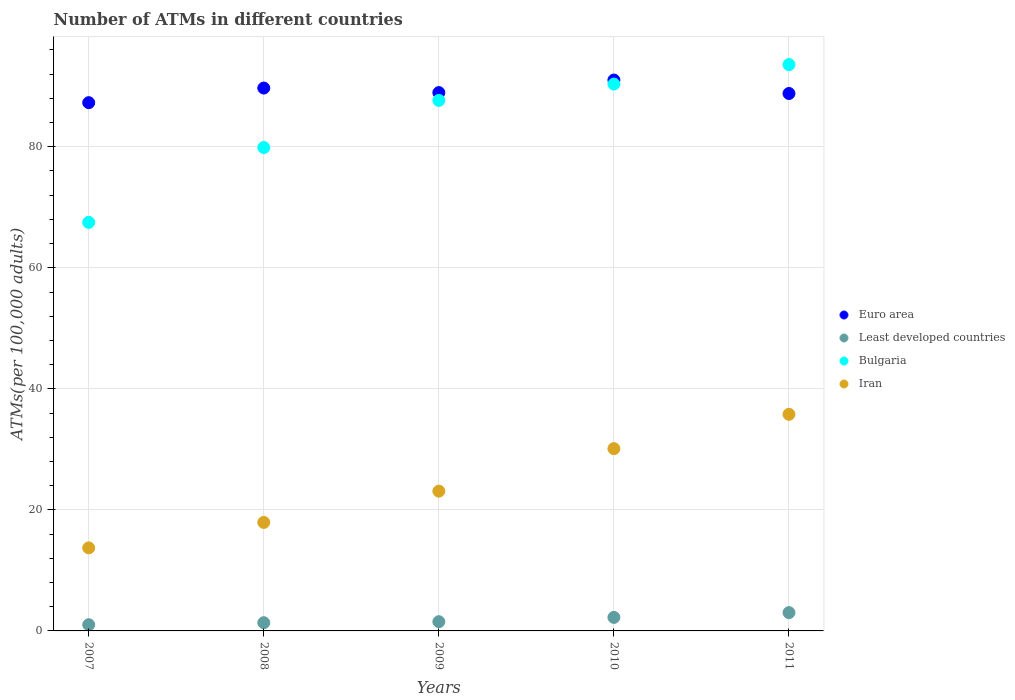How many different coloured dotlines are there?
Keep it short and to the point. 4. Is the number of dotlines equal to the number of legend labels?
Ensure brevity in your answer.  Yes. What is the number of ATMs in Euro area in 2007?
Provide a succinct answer. 87.29. Across all years, what is the maximum number of ATMs in Euro area?
Make the answer very short. 91.03. Across all years, what is the minimum number of ATMs in Bulgaria?
Your answer should be very brief. 67.51. In which year was the number of ATMs in Iran minimum?
Give a very brief answer. 2007. What is the total number of ATMs in Bulgaria in the graph?
Give a very brief answer. 419. What is the difference between the number of ATMs in Least developed countries in 2008 and that in 2010?
Offer a terse response. -0.87. What is the difference between the number of ATMs in Iran in 2010 and the number of ATMs in Least developed countries in 2008?
Make the answer very short. 28.76. What is the average number of ATMs in Least developed countries per year?
Provide a short and direct response. 1.83. In the year 2009, what is the difference between the number of ATMs in Least developed countries and number of ATMs in Bulgaria?
Keep it short and to the point. -86.14. In how many years, is the number of ATMs in Euro area greater than 64?
Offer a terse response. 5. What is the ratio of the number of ATMs in Iran in 2009 to that in 2010?
Keep it short and to the point. 0.77. Is the number of ATMs in Iran in 2007 less than that in 2011?
Keep it short and to the point. Yes. Is the difference between the number of ATMs in Least developed countries in 2008 and 2009 greater than the difference between the number of ATMs in Bulgaria in 2008 and 2009?
Provide a short and direct response. Yes. What is the difference between the highest and the second highest number of ATMs in Iran?
Your answer should be compact. 5.67. What is the difference between the highest and the lowest number of ATMs in Least developed countries?
Provide a succinct answer. 2. Is it the case that in every year, the sum of the number of ATMs in Iran and number of ATMs in Euro area  is greater than the sum of number of ATMs in Bulgaria and number of ATMs in Least developed countries?
Offer a very short reply. No. Is it the case that in every year, the sum of the number of ATMs in Least developed countries and number of ATMs in Bulgaria  is greater than the number of ATMs in Iran?
Keep it short and to the point. Yes. Is the number of ATMs in Least developed countries strictly less than the number of ATMs in Bulgaria over the years?
Your response must be concise. Yes. How many years are there in the graph?
Keep it short and to the point. 5. What is the difference between two consecutive major ticks on the Y-axis?
Your answer should be very brief. 20. Are the values on the major ticks of Y-axis written in scientific E-notation?
Give a very brief answer. No. Does the graph contain grids?
Provide a short and direct response. Yes. Where does the legend appear in the graph?
Offer a terse response. Center right. What is the title of the graph?
Ensure brevity in your answer.  Number of ATMs in different countries. Does "High income: nonOECD" appear as one of the legend labels in the graph?
Give a very brief answer. No. What is the label or title of the X-axis?
Offer a terse response. Years. What is the label or title of the Y-axis?
Your response must be concise. ATMs(per 100,0 adults). What is the ATMs(per 100,000 adults) in Euro area in 2007?
Keep it short and to the point. 87.29. What is the ATMs(per 100,000 adults) in Least developed countries in 2007?
Offer a terse response. 1.03. What is the ATMs(per 100,000 adults) in Bulgaria in 2007?
Your answer should be compact. 67.51. What is the ATMs(per 100,000 adults) in Iran in 2007?
Your answer should be compact. 13.73. What is the ATMs(per 100,000 adults) in Euro area in 2008?
Make the answer very short. 89.71. What is the ATMs(per 100,000 adults) of Least developed countries in 2008?
Give a very brief answer. 1.36. What is the ATMs(per 100,000 adults) of Bulgaria in 2008?
Offer a very short reply. 79.88. What is the ATMs(per 100,000 adults) in Iran in 2008?
Provide a short and direct response. 17.93. What is the ATMs(per 100,000 adults) in Euro area in 2009?
Your response must be concise. 88.96. What is the ATMs(per 100,000 adults) in Least developed countries in 2009?
Your answer should be compact. 1.53. What is the ATMs(per 100,000 adults) in Bulgaria in 2009?
Offer a terse response. 87.66. What is the ATMs(per 100,000 adults) in Iran in 2009?
Give a very brief answer. 23.09. What is the ATMs(per 100,000 adults) of Euro area in 2010?
Give a very brief answer. 91.03. What is the ATMs(per 100,000 adults) in Least developed countries in 2010?
Your answer should be compact. 2.23. What is the ATMs(per 100,000 adults) in Bulgaria in 2010?
Offer a very short reply. 90.36. What is the ATMs(per 100,000 adults) in Iran in 2010?
Your answer should be compact. 30.12. What is the ATMs(per 100,000 adults) of Euro area in 2011?
Ensure brevity in your answer.  88.81. What is the ATMs(per 100,000 adults) in Least developed countries in 2011?
Provide a succinct answer. 3.02. What is the ATMs(per 100,000 adults) of Bulgaria in 2011?
Offer a terse response. 93.58. What is the ATMs(per 100,000 adults) in Iran in 2011?
Provide a succinct answer. 35.79. Across all years, what is the maximum ATMs(per 100,000 adults) in Euro area?
Keep it short and to the point. 91.03. Across all years, what is the maximum ATMs(per 100,000 adults) in Least developed countries?
Your answer should be compact. 3.02. Across all years, what is the maximum ATMs(per 100,000 adults) in Bulgaria?
Keep it short and to the point. 93.58. Across all years, what is the maximum ATMs(per 100,000 adults) of Iran?
Your response must be concise. 35.79. Across all years, what is the minimum ATMs(per 100,000 adults) of Euro area?
Your response must be concise. 87.29. Across all years, what is the minimum ATMs(per 100,000 adults) of Least developed countries?
Offer a terse response. 1.03. Across all years, what is the minimum ATMs(per 100,000 adults) of Bulgaria?
Ensure brevity in your answer.  67.51. Across all years, what is the minimum ATMs(per 100,000 adults) of Iran?
Make the answer very short. 13.73. What is the total ATMs(per 100,000 adults) in Euro area in the graph?
Provide a succinct answer. 445.79. What is the total ATMs(per 100,000 adults) in Least developed countries in the graph?
Provide a succinct answer. 9.17. What is the total ATMs(per 100,000 adults) in Bulgaria in the graph?
Make the answer very short. 419. What is the total ATMs(per 100,000 adults) of Iran in the graph?
Keep it short and to the point. 120.67. What is the difference between the ATMs(per 100,000 adults) of Euro area in 2007 and that in 2008?
Provide a succinct answer. -2.42. What is the difference between the ATMs(per 100,000 adults) of Least developed countries in 2007 and that in 2008?
Offer a terse response. -0.33. What is the difference between the ATMs(per 100,000 adults) in Bulgaria in 2007 and that in 2008?
Ensure brevity in your answer.  -12.37. What is the difference between the ATMs(per 100,000 adults) of Iran in 2007 and that in 2008?
Your answer should be compact. -4.2. What is the difference between the ATMs(per 100,000 adults) of Euro area in 2007 and that in 2009?
Your response must be concise. -1.67. What is the difference between the ATMs(per 100,000 adults) of Least developed countries in 2007 and that in 2009?
Offer a very short reply. -0.5. What is the difference between the ATMs(per 100,000 adults) in Bulgaria in 2007 and that in 2009?
Keep it short and to the point. -20.16. What is the difference between the ATMs(per 100,000 adults) in Iran in 2007 and that in 2009?
Provide a succinct answer. -9.37. What is the difference between the ATMs(per 100,000 adults) of Euro area in 2007 and that in 2010?
Your answer should be very brief. -3.74. What is the difference between the ATMs(per 100,000 adults) in Least developed countries in 2007 and that in 2010?
Your answer should be compact. -1.21. What is the difference between the ATMs(per 100,000 adults) in Bulgaria in 2007 and that in 2010?
Your response must be concise. -22.86. What is the difference between the ATMs(per 100,000 adults) of Iran in 2007 and that in 2010?
Your answer should be very brief. -16.4. What is the difference between the ATMs(per 100,000 adults) of Euro area in 2007 and that in 2011?
Keep it short and to the point. -1.52. What is the difference between the ATMs(per 100,000 adults) in Least developed countries in 2007 and that in 2011?
Offer a terse response. -2. What is the difference between the ATMs(per 100,000 adults) in Bulgaria in 2007 and that in 2011?
Ensure brevity in your answer.  -26.08. What is the difference between the ATMs(per 100,000 adults) of Iran in 2007 and that in 2011?
Make the answer very short. -22.07. What is the difference between the ATMs(per 100,000 adults) in Euro area in 2008 and that in 2009?
Keep it short and to the point. 0.75. What is the difference between the ATMs(per 100,000 adults) in Least developed countries in 2008 and that in 2009?
Offer a very short reply. -0.17. What is the difference between the ATMs(per 100,000 adults) of Bulgaria in 2008 and that in 2009?
Your response must be concise. -7.78. What is the difference between the ATMs(per 100,000 adults) of Iran in 2008 and that in 2009?
Offer a very short reply. -5.17. What is the difference between the ATMs(per 100,000 adults) in Euro area in 2008 and that in 2010?
Make the answer very short. -1.32. What is the difference between the ATMs(per 100,000 adults) of Least developed countries in 2008 and that in 2010?
Offer a terse response. -0.87. What is the difference between the ATMs(per 100,000 adults) of Bulgaria in 2008 and that in 2010?
Make the answer very short. -10.48. What is the difference between the ATMs(per 100,000 adults) of Iran in 2008 and that in 2010?
Provide a succinct answer. -12.19. What is the difference between the ATMs(per 100,000 adults) of Euro area in 2008 and that in 2011?
Provide a succinct answer. 0.9. What is the difference between the ATMs(per 100,000 adults) in Least developed countries in 2008 and that in 2011?
Your answer should be very brief. -1.66. What is the difference between the ATMs(per 100,000 adults) of Bulgaria in 2008 and that in 2011?
Ensure brevity in your answer.  -13.7. What is the difference between the ATMs(per 100,000 adults) in Iran in 2008 and that in 2011?
Offer a terse response. -17.86. What is the difference between the ATMs(per 100,000 adults) of Euro area in 2009 and that in 2010?
Provide a short and direct response. -2.07. What is the difference between the ATMs(per 100,000 adults) of Least developed countries in 2009 and that in 2010?
Offer a terse response. -0.71. What is the difference between the ATMs(per 100,000 adults) of Bulgaria in 2009 and that in 2010?
Ensure brevity in your answer.  -2.7. What is the difference between the ATMs(per 100,000 adults) in Iran in 2009 and that in 2010?
Your response must be concise. -7.03. What is the difference between the ATMs(per 100,000 adults) of Euro area in 2009 and that in 2011?
Provide a short and direct response. 0.15. What is the difference between the ATMs(per 100,000 adults) of Least developed countries in 2009 and that in 2011?
Give a very brief answer. -1.5. What is the difference between the ATMs(per 100,000 adults) of Bulgaria in 2009 and that in 2011?
Keep it short and to the point. -5.92. What is the difference between the ATMs(per 100,000 adults) in Iran in 2009 and that in 2011?
Your answer should be very brief. -12.7. What is the difference between the ATMs(per 100,000 adults) in Euro area in 2010 and that in 2011?
Offer a terse response. 2.22. What is the difference between the ATMs(per 100,000 adults) in Least developed countries in 2010 and that in 2011?
Your answer should be very brief. -0.79. What is the difference between the ATMs(per 100,000 adults) in Bulgaria in 2010 and that in 2011?
Offer a very short reply. -3.22. What is the difference between the ATMs(per 100,000 adults) in Iran in 2010 and that in 2011?
Ensure brevity in your answer.  -5.67. What is the difference between the ATMs(per 100,000 adults) in Euro area in 2007 and the ATMs(per 100,000 adults) in Least developed countries in 2008?
Provide a succinct answer. 85.93. What is the difference between the ATMs(per 100,000 adults) in Euro area in 2007 and the ATMs(per 100,000 adults) in Bulgaria in 2008?
Offer a terse response. 7.41. What is the difference between the ATMs(per 100,000 adults) in Euro area in 2007 and the ATMs(per 100,000 adults) in Iran in 2008?
Your answer should be compact. 69.36. What is the difference between the ATMs(per 100,000 adults) in Least developed countries in 2007 and the ATMs(per 100,000 adults) in Bulgaria in 2008?
Give a very brief answer. -78.85. What is the difference between the ATMs(per 100,000 adults) of Least developed countries in 2007 and the ATMs(per 100,000 adults) of Iran in 2008?
Keep it short and to the point. -16.9. What is the difference between the ATMs(per 100,000 adults) of Bulgaria in 2007 and the ATMs(per 100,000 adults) of Iran in 2008?
Your response must be concise. 49.58. What is the difference between the ATMs(per 100,000 adults) in Euro area in 2007 and the ATMs(per 100,000 adults) in Least developed countries in 2009?
Provide a short and direct response. 85.76. What is the difference between the ATMs(per 100,000 adults) of Euro area in 2007 and the ATMs(per 100,000 adults) of Bulgaria in 2009?
Keep it short and to the point. -0.37. What is the difference between the ATMs(per 100,000 adults) of Euro area in 2007 and the ATMs(per 100,000 adults) of Iran in 2009?
Your answer should be very brief. 64.2. What is the difference between the ATMs(per 100,000 adults) of Least developed countries in 2007 and the ATMs(per 100,000 adults) of Bulgaria in 2009?
Offer a terse response. -86.64. What is the difference between the ATMs(per 100,000 adults) of Least developed countries in 2007 and the ATMs(per 100,000 adults) of Iran in 2009?
Provide a succinct answer. -22.07. What is the difference between the ATMs(per 100,000 adults) in Bulgaria in 2007 and the ATMs(per 100,000 adults) in Iran in 2009?
Make the answer very short. 44.41. What is the difference between the ATMs(per 100,000 adults) in Euro area in 2007 and the ATMs(per 100,000 adults) in Least developed countries in 2010?
Your answer should be very brief. 85.06. What is the difference between the ATMs(per 100,000 adults) of Euro area in 2007 and the ATMs(per 100,000 adults) of Bulgaria in 2010?
Ensure brevity in your answer.  -3.07. What is the difference between the ATMs(per 100,000 adults) in Euro area in 2007 and the ATMs(per 100,000 adults) in Iran in 2010?
Provide a short and direct response. 57.17. What is the difference between the ATMs(per 100,000 adults) of Least developed countries in 2007 and the ATMs(per 100,000 adults) of Bulgaria in 2010?
Your answer should be compact. -89.34. What is the difference between the ATMs(per 100,000 adults) of Least developed countries in 2007 and the ATMs(per 100,000 adults) of Iran in 2010?
Offer a very short reply. -29.1. What is the difference between the ATMs(per 100,000 adults) in Bulgaria in 2007 and the ATMs(per 100,000 adults) in Iran in 2010?
Give a very brief answer. 37.38. What is the difference between the ATMs(per 100,000 adults) of Euro area in 2007 and the ATMs(per 100,000 adults) of Least developed countries in 2011?
Keep it short and to the point. 84.27. What is the difference between the ATMs(per 100,000 adults) in Euro area in 2007 and the ATMs(per 100,000 adults) in Bulgaria in 2011?
Offer a terse response. -6.29. What is the difference between the ATMs(per 100,000 adults) of Euro area in 2007 and the ATMs(per 100,000 adults) of Iran in 2011?
Your answer should be very brief. 51.5. What is the difference between the ATMs(per 100,000 adults) in Least developed countries in 2007 and the ATMs(per 100,000 adults) in Bulgaria in 2011?
Offer a very short reply. -92.56. What is the difference between the ATMs(per 100,000 adults) of Least developed countries in 2007 and the ATMs(per 100,000 adults) of Iran in 2011?
Provide a succinct answer. -34.77. What is the difference between the ATMs(per 100,000 adults) in Bulgaria in 2007 and the ATMs(per 100,000 adults) in Iran in 2011?
Your response must be concise. 31.71. What is the difference between the ATMs(per 100,000 adults) in Euro area in 2008 and the ATMs(per 100,000 adults) in Least developed countries in 2009?
Keep it short and to the point. 88.18. What is the difference between the ATMs(per 100,000 adults) of Euro area in 2008 and the ATMs(per 100,000 adults) of Bulgaria in 2009?
Offer a terse response. 2.04. What is the difference between the ATMs(per 100,000 adults) in Euro area in 2008 and the ATMs(per 100,000 adults) in Iran in 2009?
Make the answer very short. 66.61. What is the difference between the ATMs(per 100,000 adults) of Least developed countries in 2008 and the ATMs(per 100,000 adults) of Bulgaria in 2009?
Your answer should be very brief. -86.3. What is the difference between the ATMs(per 100,000 adults) in Least developed countries in 2008 and the ATMs(per 100,000 adults) in Iran in 2009?
Keep it short and to the point. -21.73. What is the difference between the ATMs(per 100,000 adults) of Bulgaria in 2008 and the ATMs(per 100,000 adults) of Iran in 2009?
Your answer should be compact. 56.79. What is the difference between the ATMs(per 100,000 adults) in Euro area in 2008 and the ATMs(per 100,000 adults) in Least developed countries in 2010?
Keep it short and to the point. 87.47. What is the difference between the ATMs(per 100,000 adults) in Euro area in 2008 and the ATMs(per 100,000 adults) in Bulgaria in 2010?
Keep it short and to the point. -0.66. What is the difference between the ATMs(per 100,000 adults) of Euro area in 2008 and the ATMs(per 100,000 adults) of Iran in 2010?
Give a very brief answer. 59.58. What is the difference between the ATMs(per 100,000 adults) of Least developed countries in 2008 and the ATMs(per 100,000 adults) of Bulgaria in 2010?
Your answer should be very brief. -89. What is the difference between the ATMs(per 100,000 adults) of Least developed countries in 2008 and the ATMs(per 100,000 adults) of Iran in 2010?
Make the answer very short. -28.76. What is the difference between the ATMs(per 100,000 adults) of Bulgaria in 2008 and the ATMs(per 100,000 adults) of Iran in 2010?
Provide a succinct answer. 49.76. What is the difference between the ATMs(per 100,000 adults) in Euro area in 2008 and the ATMs(per 100,000 adults) in Least developed countries in 2011?
Offer a terse response. 86.68. What is the difference between the ATMs(per 100,000 adults) in Euro area in 2008 and the ATMs(per 100,000 adults) in Bulgaria in 2011?
Ensure brevity in your answer.  -3.88. What is the difference between the ATMs(per 100,000 adults) of Euro area in 2008 and the ATMs(per 100,000 adults) of Iran in 2011?
Provide a succinct answer. 53.91. What is the difference between the ATMs(per 100,000 adults) in Least developed countries in 2008 and the ATMs(per 100,000 adults) in Bulgaria in 2011?
Give a very brief answer. -92.22. What is the difference between the ATMs(per 100,000 adults) of Least developed countries in 2008 and the ATMs(per 100,000 adults) of Iran in 2011?
Your answer should be very brief. -34.43. What is the difference between the ATMs(per 100,000 adults) in Bulgaria in 2008 and the ATMs(per 100,000 adults) in Iran in 2011?
Make the answer very short. 44.09. What is the difference between the ATMs(per 100,000 adults) in Euro area in 2009 and the ATMs(per 100,000 adults) in Least developed countries in 2010?
Your answer should be very brief. 86.72. What is the difference between the ATMs(per 100,000 adults) in Euro area in 2009 and the ATMs(per 100,000 adults) in Bulgaria in 2010?
Your answer should be compact. -1.41. What is the difference between the ATMs(per 100,000 adults) of Euro area in 2009 and the ATMs(per 100,000 adults) of Iran in 2010?
Your answer should be compact. 58.83. What is the difference between the ATMs(per 100,000 adults) in Least developed countries in 2009 and the ATMs(per 100,000 adults) in Bulgaria in 2010?
Make the answer very short. -88.84. What is the difference between the ATMs(per 100,000 adults) in Least developed countries in 2009 and the ATMs(per 100,000 adults) in Iran in 2010?
Ensure brevity in your answer.  -28.6. What is the difference between the ATMs(per 100,000 adults) of Bulgaria in 2009 and the ATMs(per 100,000 adults) of Iran in 2010?
Offer a terse response. 57.54. What is the difference between the ATMs(per 100,000 adults) in Euro area in 2009 and the ATMs(per 100,000 adults) in Least developed countries in 2011?
Keep it short and to the point. 85.93. What is the difference between the ATMs(per 100,000 adults) of Euro area in 2009 and the ATMs(per 100,000 adults) of Bulgaria in 2011?
Offer a terse response. -4.63. What is the difference between the ATMs(per 100,000 adults) in Euro area in 2009 and the ATMs(per 100,000 adults) in Iran in 2011?
Your answer should be very brief. 53.16. What is the difference between the ATMs(per 100,000 adults) in Least developed countries in 2009 and the ATMs(per 100,000 adults) in Bulgaria in 2011?
Your answer should be compact. -92.06. What is the difference between the ATMs(per 100,000 adults) in Least developed countries in 2009 and the ATMs(per 100,000 adults) in Iran in 2011?
Ensure brevity in your answer.  -34.27. What is the difference between the ATMs(per 100,000 adults) in Bulgaria in 2009 and the ATMs(per 100,000 adults) in Iran in 2011?
Give a very brief answer. 51.87. What is the difference between the ATMs(per 100,000 adults) of Euro area in 2010 and the ATMs(per 100,000 adults) of Least developed countries in 2011?
Make the answer very short. 88. What is the difference between the ATMs(per 100,000 adults) in Euro area in 2010 and the ATMs(per 100,000 adults) in Bulgaria in 2011?
Provide a short and direct response. -2.55. What is the difference between the ATMs(per 100,000 adults) in Euro area in 2010 and the ATMs(per 100,000 adults) in Iran in 2011?
Ensure brevity in your answer.  55.24. What is the difference between the ATMs(per 100,000 adults) in Least developed countries in 2010 and the ATMs(per 100,000 adults) in Bulgaria in 2011?
Give a very brief answer. -91.35. What is the difference between the ATMs(per 100,000 adults) of Least developed countries in 2010 and the ATMs(per 100,000 adults) of Iran in 2011?
Provide a succinct answer. -33.56. What is the difference between the ATMs(per 100,000 adults) in Bulgaria in 2010 and the ATMs(per 100,000 adults) in Iran in 2011?
Give a very brief answer. 54.57. What is the average ATMs(per 100,000 adults) of Euro area per year?
Provide a short and direct response. 89.16. What is the average ATMs(per 100,000 adults) of Least developed countries per year?
Offer a very short reply. 1.83. What is the average ATMs(per 100,000 adults) in Bulgaria per year?
Offer a terse response. 83.8. What is the average ATMs(per 100,000 adults) in Iran per year?
Give a very brief answer. 24.13. In the year 2007, what is the difference between the ATMs(per 100,000 adults) in Euro area and ATMs(per 100,000 adults) in Least developed countries?
Offer a very short reply. 86.26. In the year 2007, what is the difference between the ATMs(per 100,000 adults) of Euro area and ATMs(per 100,000 adults) of Bulgaria?
Make the answer very short. 19.78. In the year 2007, what is the difference between the ATMs(per 100,000 adults) of Euro area and ATMs(per 100,000 adults) of Iran?
Give a very brief answer. 73.56. In the year 2007, what is the difference between the ATMs(per 100,000 adults) of Least developed countries and ATMs(per 100,000 adults) of Bulgaria?
Provide a short and direct response. -66.48. In the year 2007, what is the difference between the ATMs(per 100,000 adults) in Least developed countries and ATMs(per 100,000 adults) in Iran?
Keep it short and to the point. -12.7. In the year 2007, what is the difference between the ATMs(per 100,000 adults) in Bulgaria and ATMs(per 100,000 adults) in Iran?
Your answer should be very brief. 53.78. In the year 2008, what is the difference between the ATMs(per 100,000 adults) of Euro area and ATMs(per 100,000 adults) of Least developed countries?
Provide a short and direct response. 88.34. In the year 2008, what is the difference between the ATMs(per 100,000 adults) in Euro area and ATMs(per 100,000 adults) in Bulgaria?
Offer a terse response. 9.82. In the year 2008, what is the difference between the ATMs(per 100,000 adults) in Euro area and ATMs(per 100,000 adults) in Iran?
Your answer should be very brief. 71.78. In the year 2008, what is the difference between the ATMs(per 100,000 adults) of Least developed countries and ATMs(per 100,000 adults) of Bulgaria?
Offer a very short reply. -78.52. In the year 2008, what is the difference between the ATMs(per 100,000 adults) of Least developed countries and ATMs(per 100,000 adults) of Iran?
Ensure brevity in your answer.  -16.57. In the year 2008, what is the difference between the ATMs(per 100,000 adults) in Bulgaria and ATMs(per 100,000 adults) in Iran?
Your answer should be compact. 61.95. In the year 2009, what is the difference between the ATMs(per 100,000 adults) of Euro area and ATMs(per 100,000 adults) of Least developed countries?
Your answer should be very brief. 87.43. In the year 2009, what is the difference between the ATMs(per 100,000 adults) of Euro area and ATMs(per 100,000 adults) of Bulgaria?
Keep it short and to the point. 1.29. In the year 2009, what is the difference between the ATMs(per 100,000 adults) of Euro area and ATMs(per 100,000 adults) of Iran?
Provide a succinct answer. 65.86. In the year 2009, what is the difference between the ATMs(per 100,000 adults) in Least developed countries and ATMs(per 100,000 adults) in Bulgaria?
Provide a succinct answer. -86.14. In the year 2009, what is the difference between the ATMs(per 100,000 adults) of Least developed countries and ATMs(per 100,000 adults) of Iran?
Offer a very short reply. -21.57. In the year 2009, what is the difference between the ATMs(per 100,000 adults) in Bulgaria and ATMs(per 100,000 adults) in Iran?
Offer a very short reply. 64.57. In the year 2010, what is the difference between the ATMs(per 100,000 adults) in Euro area and ATMs(per 100,000 adults) in Least developed countries?
Provide a succinct answer. 88.79. In the year 2010, what is the difference between the ATMs(per 100,000 adults) in Euro area and ATMs(per 100,000 adults) in Bulgaria?
Provide a short and direct response. 0.66. In the year 2010, what is the difference between the ATMs(per 100,000 adults) in Euro area and ATMs(per 100,000 adults) in Iran?
Your response must be concise. 60.91. In the year 2010, what is the difference between the ATMs(per 100,000 adults) in Least developed countries and ATMs(per 100,000 adults) in Bulgaria?
Your response must be concise. -88.13. In the year 2010, what is the difference between the ATMs(per 100,000 adults) of Least developed countries and ATMs(per 100,000 adults) of Iran?
Give a very brief answer. -27.89. In the year 2010, what is the difference between the ATMs(per 100,000 adults) in Bulgaria and ATMs(per 100,000 adults) in Iran?
Make the answer very short. 60.24. In the year 2011, what is the difference between the ATMs(per 100,000 adults) in Euro area and ATMs(per 100,000 adults) in Least developed countries?
Provide a succinct answer. 85.78. In the year 2011, what is the difference between the ATMs(per 100,000 adults) of Euro area and ATMs(per 100,000 adults) of Bulgaria?
Your answer should be very brief. -4.78. In the year 2011, what is the difference between the ATMs(per 100,000 adults) of Euro area and ATMs(per 100,000 adults) of Iran?
Your answer should be compact. 53.01. In the year 2011, what is the difference between the ATMs(per 100,000 adults) of Least developed countries and ATMs(per 100,000 adults) of Bulgaria?
Provide a short and direct response. -90.56. In the year 2011, what is the difference between the ATMs(per 100,000 adults) in Least developed countries and ATMs(per 100,000 adults) in Iran?
Provide a short and direct response. -32.77. In the year 2011, what is the difference between the ATMs(per 100,000 adults) of Bulgaria and ATMs(per 100,000 adults) of Iran?
Give a very brief answer. 57.79. What is the ratio of the ATMs(per 100,000 adults) of Euro area in 2007 to that in 2008?
Give a very brief answer. 0.97. What is the ratio of the ATMs(per 100,000 adults) of Least developed countries in 2007 to that in 2008?
Your answer should be very brief. 0.75. What is the ratio of the ATMs(per 100,000 adults) in Bulgaria in 2007 to that in 2008?
Your response must be concise. 0.85. What is the ratio of the ATMs(per 100,000 adults) of Iran in 2007 to that in 2008?
Offer a terse response. 0.77. What is the ratio of the ATMs(per 100,000 adults) of Euro area in 2007 to that in 2009?
Provide a succinct answer. 0.98. What is the ratio of the ATMs(per 100,000 adults) of Least developed countries in 2007 to that in 2009?
Ensure brevity in your answer.  0.67. What is the ratio of the ATMs(per 100,000 adults) in Bulgaria in 2007 to that in 2009?
Provide a succinct answer. 0.77. What is the ratio of the ATMs(per 100,000 adults) in Iran in 2007 to that in 2009?
Give a very brief answer. 0.59. What is the ratio of the ATMs(per 100,000 adults) in Euro area in 2007 to that in 2010?
Your answer should be compact. 0.96. What is the ratio of the ATMs(per 100,000 adults) in Least developed countries in 2007 to that in 2010?
Make the answer very short. 0.46. What is the ratio of the ATMs(per 100,000 adults) in Bulgaria in 2007 to that in 2010?
Keep it short and to the point. 0.75. What is the ratio of the ATMs(per 100,000 adults) in Iran in 2007 to that in 2010?
Offer a very short reply. 0.46. What is the ratio of the ATMs(per 100,000 adults) of Euro area in 2007 to that in 2011?
Ensure brevity in your answer.  0.98. What is the ratio of the ATMs(per 100,000 adults) of Least developed countries in 2007 to that in 2011?
Ensure brevity in your answer.  0.34. What is the ratio of the ATMs(per 100,000 adults) of Bulgaria in 2007 to that in 2011?
Offer a terse response. 0.72. What is the ratio of the ATMs(per 100,000 adults) of Iran in 2007 to that in 2011?
Your answer should be compact. 0.38. What is the ratio of the ATMs(per 100,000 adults) of Euro area in 2008 to that in 2009?
Give a very brief answer. 1.01. What is the ratio of the ATMs(per 100,000 adults) of Least developed countries in 2008 to that in 2009?
Your response must be concise. 0.89. What is the ratio of the ATMs(per 100,000 adults) of Bulgaria in 2008 to that in 2009?
Your answer should be compact. 0.91. What is the ratio of the ATMs(per 100,000 adults) in Iran in 2008 to that in 2009?
Make the answer very short. 0.78. What is the ratio of the ATMs(per 100,000 adults) of Euro area in 2008 to that in 2010?
Give a very brief answer. 0.99. What is the ratio of the ATMs(per 100,000 adults) of Least developed countries in 2008 to that in 2010?
Provide a short and direct response. 0.61. What is the ratio of the ATMs(per 100,000 adults) of Bulgaria in 2008 to that in 2010?
Provide a short and direct response. 0.88. What is the ratio of the ATMs(per 100,000 adults) of Iran in 2008 to that in 2010?
Your answer should be compact. 0.6. What is the ratio of the ATMs(per 100,000 adults) of Euro area in 2008 to that in 2011?
Make the answer very short. 1.01. What is the ratio of the ATMs(per 100,000 adults) of Least developed countries in 2008 to that in 2011?
Your answer should be very brief. 0.45. What is the ratio of the ATMs(per 100,000 adults) in Bulgaria in 2008 to that in 2011?
Keep it short and to the point. 0.85. What is the ratio of the ATMs(per 100,000 adults) in Iran in 2008 to that in 2011?
Your answer should be very brief. 0.5. What is the ratio of the ATMs(per 100,000 adults) in Euro area in 2009 to that in 2010?
Your answer should be compact. 0.98. What is the ratio of the ATMs(per 100,000 adults) of Least developed countries in 2009 to that in 2010?
Ensure brevity in your answer.  0.68. What is the ratio of the ATMs(per 100,000 adults) of Bulgaria in 2009 to that in 2010?
Your response must be concise. 0.97. What is the ratio of the ATMs(per 100,000 adults) in Iran in 2009 to that in 2010?
Provide a short and direct response. 0.77. What is the ratio of the ATMs(per 100,000 adults) in Euro area in 2009 to that in 2011?
Give a very brief answer. 1. What is the ratio of the ATMs(per 100,000 adults) in Least developed countries in 2009 to that in 2011?
Give a very brief answer. 0.5. What is the ratio of the ATMs(per 100,000 adults) of Bulgaria in 2009 to that in 2011?
Offer a terse response. 0.94. What is the ratio of the ATMs(per 100,000 adults) of Iran in 2009 to that in 2011?
Your answer should be very brief. 0.65. What is the ratio of the ATMs(per 100,000 adults) in Least developed countries in 2010 to that in 2011?
Your answer should be compact. 0.74. What is the ratio of the ATMs(per 100,000 adults) in Bulgaria in 2010 to that in 2011?
Make the answer very short. 0.97. What is the ratio of the ATMs(per 100,000 adults) in Iran in 2010 to that in 2011?
Provide a succinct answer. 0.84. What is the difference between the highest and the second highest ATMs(per 100,000 adults) of Euro area?
Keep it short and to the point. 1.32. What is the difference between the highest and the second highest ATMs(per 100,000 adults) in Least developed countries?
Offer a terse response. 0.79. What is the difference between the highest and the second highest ATMs(per 100,000 adults) in Bulgaria?
Provide a short and direct response. 3.22. What is the difference between the highest and the second highest ATMs(per 100,000 adults) of Iran?
Your answer should be very brief. 5.67. What is the difference between the highest and the lowest ATMs(per 100,000 adults) of Euro area?
Provide a short and direct response. 3.74. What is the difference between the highest and the lowest ATMs(per 100,000 adults) of Least developed countries?
Ensure brevity in your answer.  2. What is the difference between the highest and the lowest ATMs(per 100,000 adults) in Bulgaria?
Your answer should be very brief. 26.08. What is the difference between the highest and the lowest ATMs(per 100,000 adults) of Iran?
Your answer should be very brief. 22.07. 